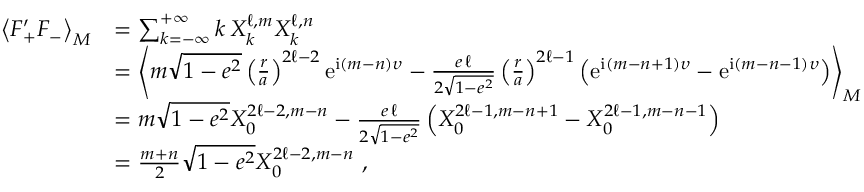<formula> <loc_0><loc_0><loc_500><loc_500>\begin{array} { r l } { \left \langle F _ { + } ^ { \prime } F _ { - } \right \rangle _ { M } } & { = \sum _ { k = - \infty } ^ { + \infty } k \, X _ { k } ^ { \ell , m } X _ { k } ^ { \ell , n } } \\ & { = \left \langle m \sqrt { 1 - e ^ { 2 } } \left ( \frac { r } { a } \right ) ^ { 2 \ell - 2 } e ^ { i ( m - n ) \upsilon } - \frac { e \, \ell } { 2 \sqrt { 1 - e ^ { 2 } } } \left ( \frac { r } { a } \right ) ^ { 2 \ell - 1 } \left ( e ^ { i ( m - n + 1 ) \upsilon } - e ^ { i ( m - n - 1 ) \upsilon } \right ) \right \rangle _ { M } } \\ & { = m \sqrt { 1 - e ^ { 2 } } X _ { 0 } ^ { 2 \ell - 2 , m - n } - \frac { e \, \ell } { 2 \sqrt { 1 - e ^ { 2 } } } \left ( X _ { 0 } ^ { 2 \ell - 1 , m - n + 1 } - X _ { 0 } ^ { 2 \ell - 1 , m - n - 1 } \right ) } \\ & { = \frac { m + n } { 2 } \sqrt { 1 - e ^ { 2 } } X _ { 0 } ^ { 2 \ell - 2 , m - n } \ , } \end{array}</formula> 